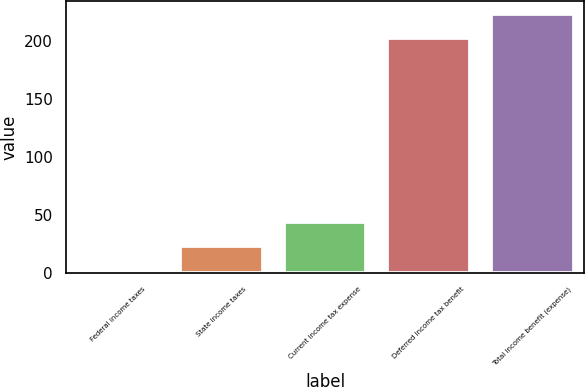Convert chart. <chart><loc_0><loc_0><loc_500><loc_500><bar_chart><fcel>Federal income taxes<fcel>State income taxes<fcel>Current income tax expense<fcel>Deferred income tax benefit<fcel>Total income benefit (expense)<nl><fcel>2<fcel>22.7<fcel>43.4<fcel>202<fcel>222.7<nl></chart> 